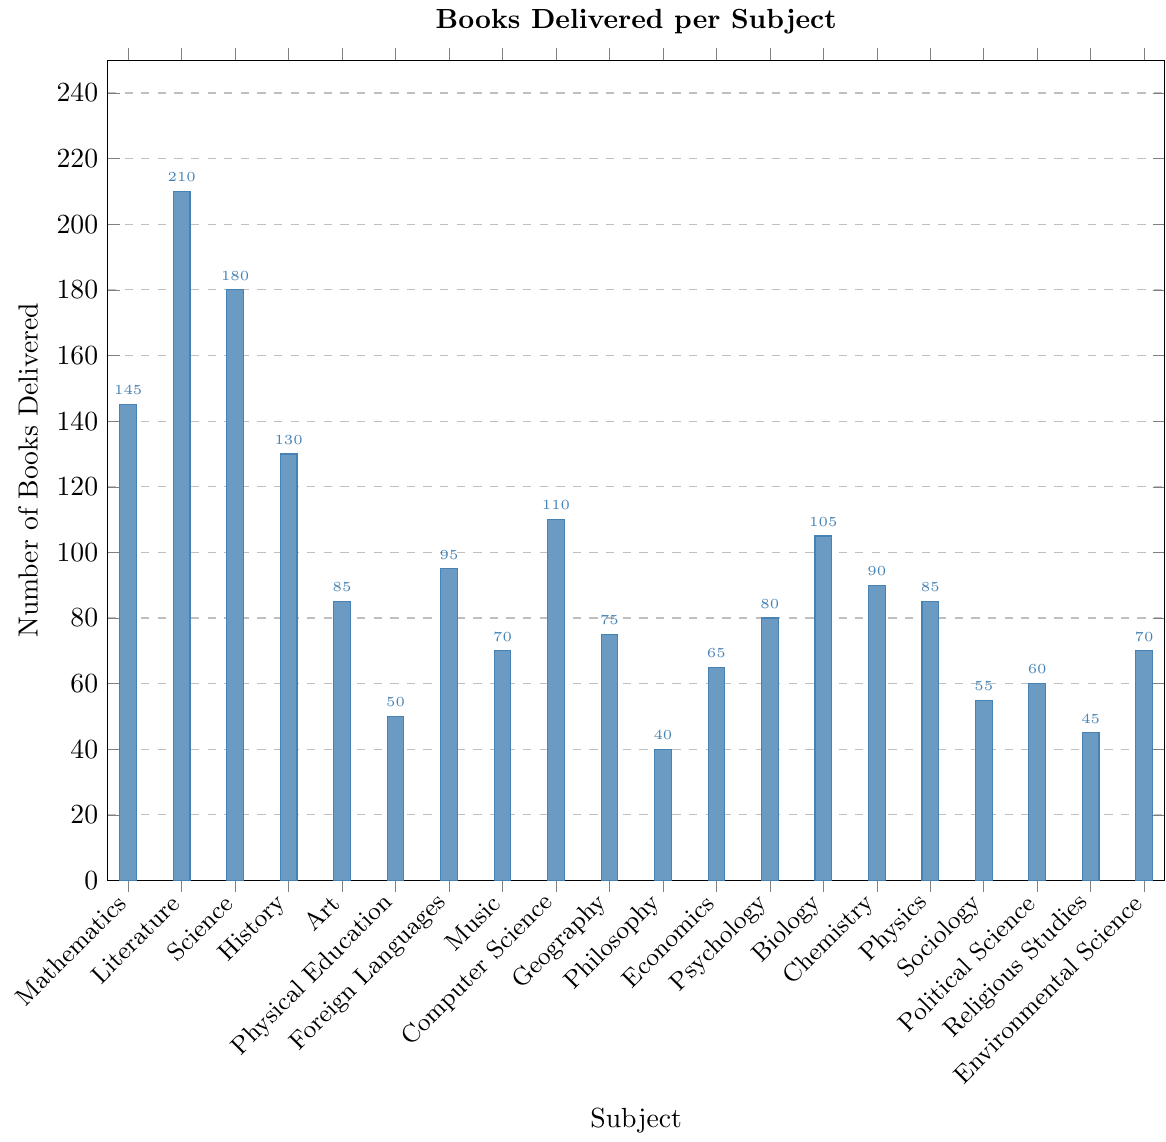What's the highest number of books delivered per subject? By looking at the bar heights, the highest bar corresponds to Literature. The number near the top of this bar is 210.
Answer: 210 Which subject received fewer books: Art or Physical Education? By comparing the bar heights, Art has a taller bar with a value of 85, while Physical Education has a shorter bar with a value of 50.
Answer: Physical Education How many more books were delivered to Science compared to History? The bar for Science is 180, and the bar for History is 130. Subtract the number of books delivered to History from the number for Science: 180 - 130 = 50.
Answer: 50 What's the combined total of books delivered for Geography and Philosophy? The bar for Geography is 75 and the bar for Philosophy is 40. Add the two values: 75 + 40 = 115.
Answer: 115 Which subjects received an equal number of books? By examining the bars, Physics and Art each have bars reaching up to 85. Both subjects received 85 books.
Answer: Physics, Art What’s the difference between the highest and the lowest number of books delivered? The highest number, seen in the Literature bar, is 210. The lowest number, seen in the Philosophy bar, is 40. Subtract the smallest from the largest: 210 - 40 = 170.
Answer: 170 How does the number of books delivered to Mathematics compare with Chemistry? Mathematics has a bar reaching up to 145, and Chemistry has a bar at 90. Mathematics received more books.
Answer: Mathematics Which subject received the median number of books? After ordering the values from smallest to largest, the middle value (median) is at the 10th position: 85 (Art and Physics).
Answer: Art, Physics Calculate the average number of books delivered over all subjects. Sum all the values and divide by the number of subjects: (145 + 210 + 180 + 130 + 85 + 50 + 95 + 70 + 110 + 75 + 40 + 65 + 80 + 105 + 90 + 85 + 55 + 60 + 45 + 70) / 20 = 96.5.
Answer: 96.5 How many subjects received more than 100 books? By observing the bar heights, the subjects are: Mathematics, Literature, Science, Computer Science, and Biology. That's 5 subjects.
Answer: 5 